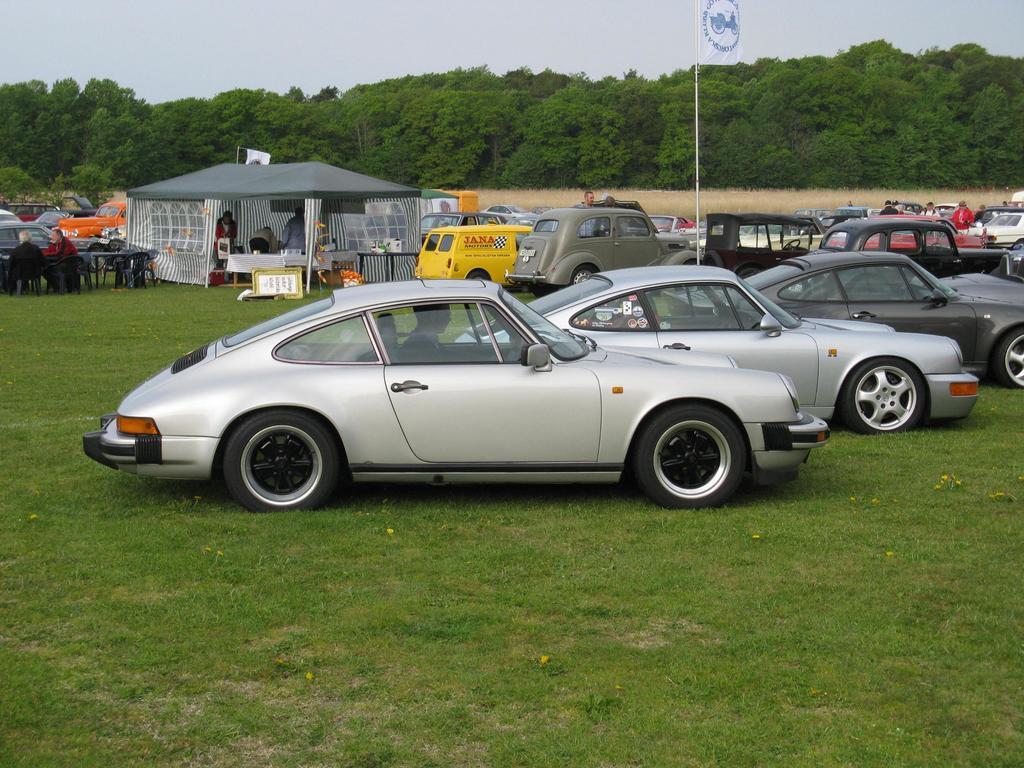Could you give a brief overview of what you see in this image? In this image there are cars in a field and there is a tent, near the tent there are table and few people are sitting on chairs, in the background there are trees and the sky. 